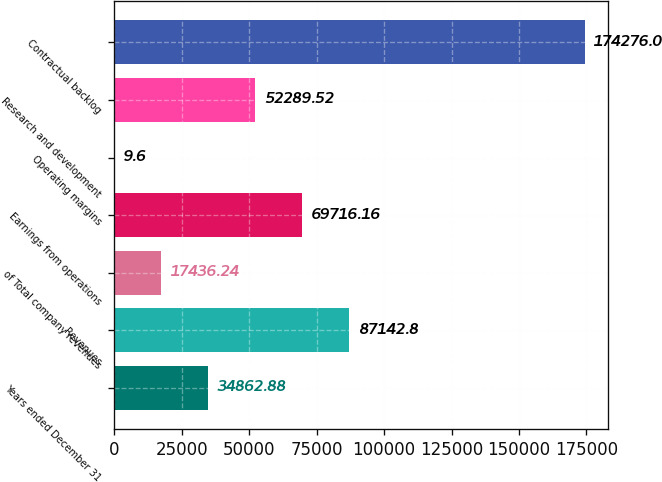<chart> <loc_0><loc_0><loc_500><loc_500><bar_chart><fcel>Years ended December 31<fcel>Revenues<fcel>of Total company revenues<fcel>Earnings from operations<fcel>Operating margins<fcel>Research and development<fcel>Contractual backlog<nl><fcel>34862.9<fcel>87142.8<fcel>17436.2<fcel>69716.2<fcel>9.6<fcel>52289.5<fcel>174276<nl></chart> 